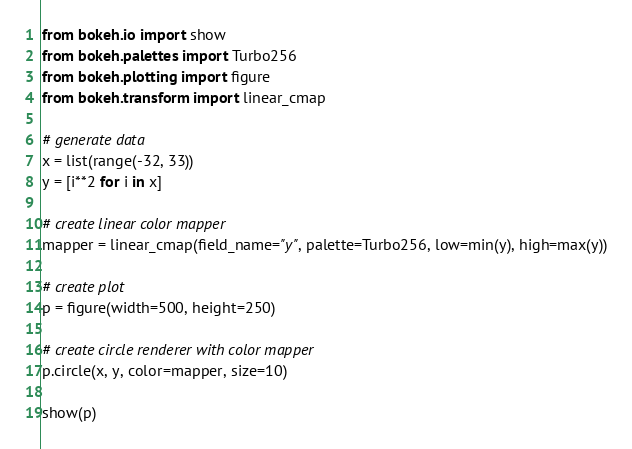Convert code to text. <code><loc_0><loc_0><loc_500><loc_500><_Python_>from bokeh.io import show
from bokeh.palettes import Turbo256
from bokeh.plotting import figure
from bokeh.transform import linear_cmap

# generate data
x = list(range(-32, 33))
y = [i**2 for i in x]

# create linear color mapper
mapper = linear_cmap(field_name="y", palette=Turbo256, low=min(y), high=max(y))

# create plot
p = figure(width=500, height=250)

# create circle renderer with color mapper
p.circle(x, y, color=mapper, size=10)

show(p)
</code> 